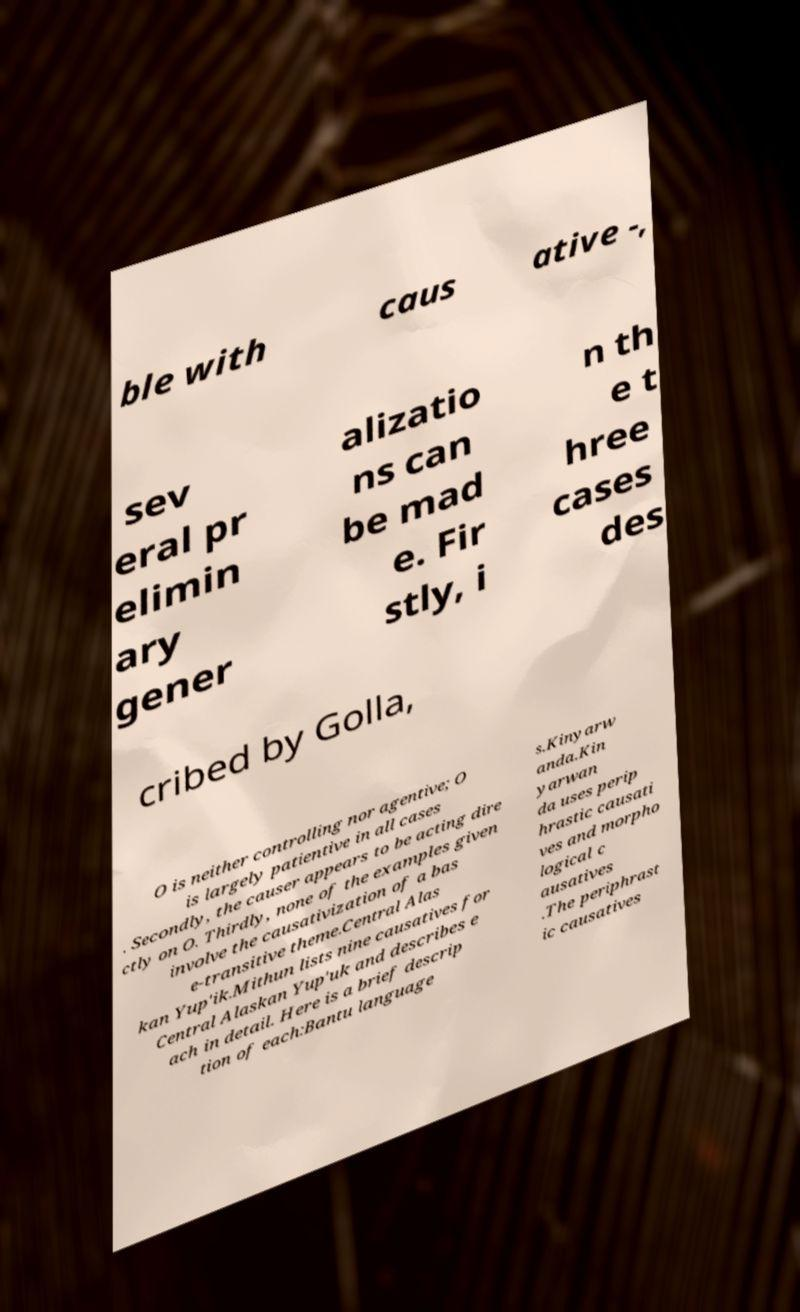There's text embedded in this image that I need extracted. Can you transcribe it verbatim? ble with caus ative -, sev eral pr elimin ary gener alizatio ns can be mad e. Fir stly, i n th e t hree cases des cribed by Golla, O is neither controlling nor agentive; O is largely patientive in all cases . Secondly, the causer appears to be acting dire ctly on O. Thirdly, none of the examples given involve the causativization of a bas e-transitive theme.Central Alas kan Yup'ik.Mithun lists nine causatives for Central Alaskan Yup'uk and describes e ach in detail. Here is a brief descrip tion of each:Bantu language s.Kinyarw anda.Kin yarwan da uses perip hrastic causati ves and morpho logical c ausatives .The periphrast ic causatives 